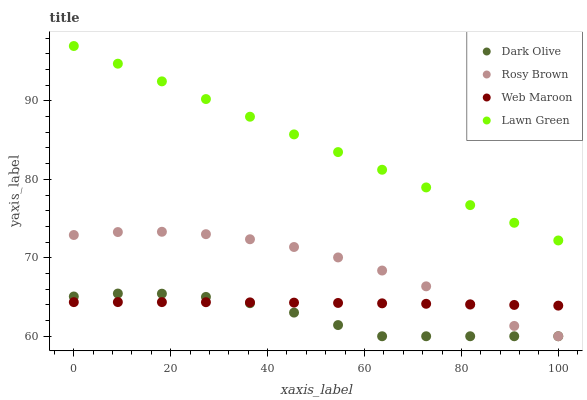Does Dark Olive have the minimum area under the curve?
Answer yes or no. Yes. Does Lawn Green have the maximum area under the curve?
Answer yes or no. Yes. Does Rosy Brown have the minimum area under the curve?
Answer yes or no. No. Does Rosy Brown have the maximum area under the curve?
Answer yes or no. No. Is Lawn Green the smoothest?
Answer yes or no. Yes. Is Rosy Brown the roughest?
Answer yes or no. Yes. Is Dark Olive the smoothest?
Answer yes or no. No. Is Dark Olive the roughest?
Answer yes or no. No. Does Rosy Brown have the lowest value?
Answer yes or no. Yes. Does Web Maroon have the lowest value?
Answer yes or no. No. Does Lawn Green have the highest value?
Answer yes or no. Yes. Does Rosy Brown have the highest value?
Answer yes or no. No. Is Dark Olive less than Lawn Green?
Answer yes or no. Yes. Is Lawn Green greater than Dark Olive?
Answer yes or no. Yes. Does Dark Olive intersect Rosy Brown?
Answer yes or no. Yes. Is Dark Olive less than Rosy Brown?
Answer yes or no. No. Is Dark Olive greater than Rosy Brown?
Answer yes or no. No. Does Dark Olive intersect Lawn Green?
Answer yes or no. No. 